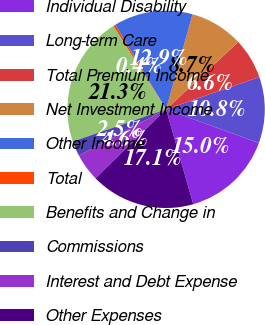Convert chart. <chart><loc_0><loc_0><loc_500><loc_500><pie_chart><fcel>Individual Disability<fcel>Long-term Care<fcel>Total Premium Income<fcel>Net Investment Income<fcel>Other Income<fcel>Total<fcel>Benefits and Change in<fcel>Commissions<fcel>Interest and Debt Expense<fcel>Other Expenses<nl><fcel>15.03%<fcel>10.84%<fcel>6.65%<fcel>8.74%<fcel>12.93%<fcel>0.37%<fcel>21.31%<fcel>2.46%<fcel>4.56%<fcel>17.12%<nl></chart> 